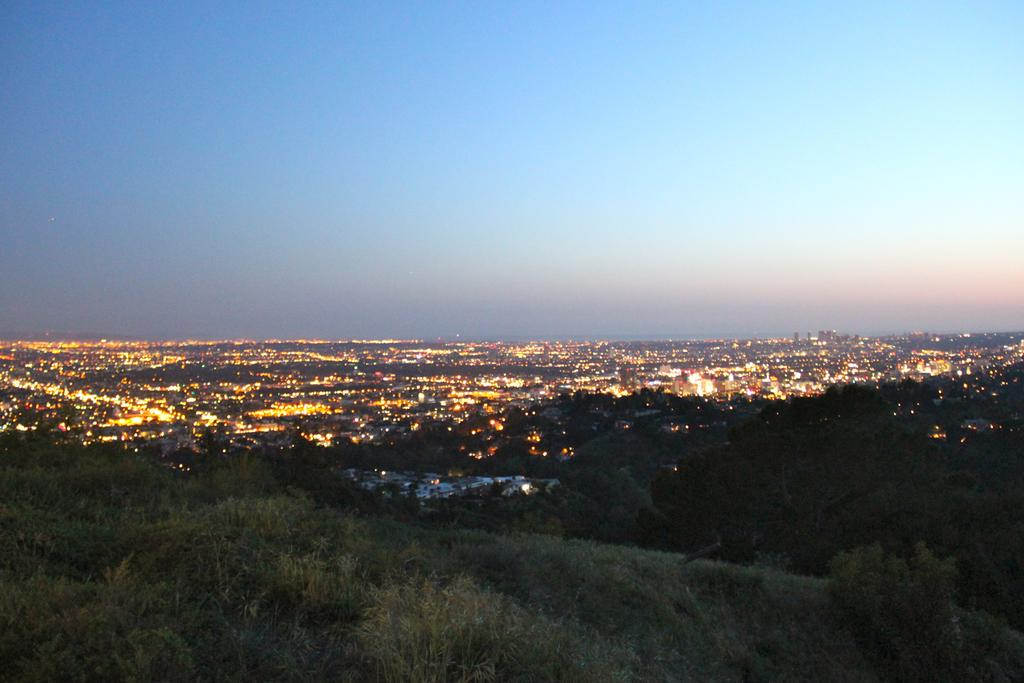What type of vegetation can be seen in the image? There are trees in the image. What objects are providing illumination in the image? There are lights in the image. What can be seen in the background of the image? The sky is visible in the background of the image. How many fingers are visible in the image? There are no fingers visible in the image. Is there a source of water present in the image? There is no source of water present in the image. 